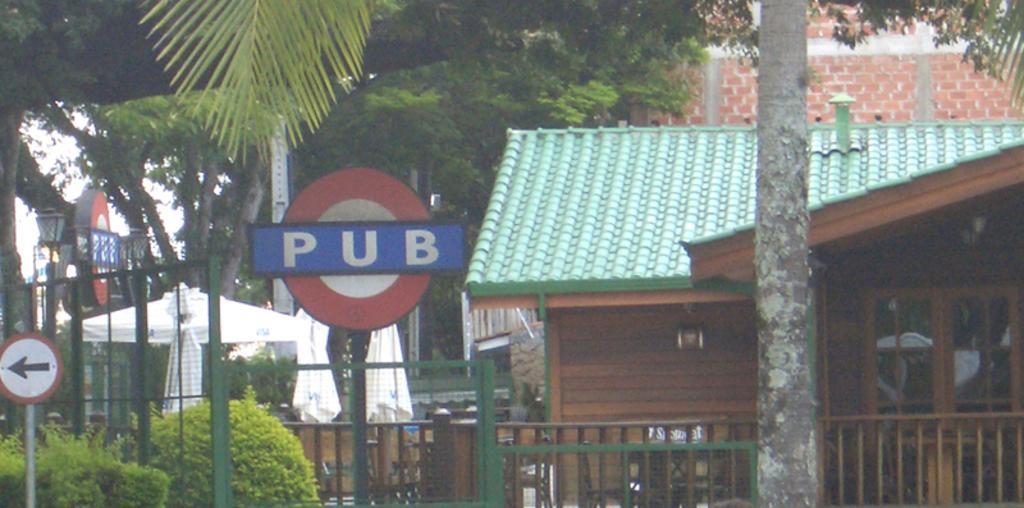Please provide a concise description of this image. This is the picture of a city. In this image there are buildings and trees and there are poles. At the back there are umbrellas and and there is a boards on the poles. At the top there is sky. 